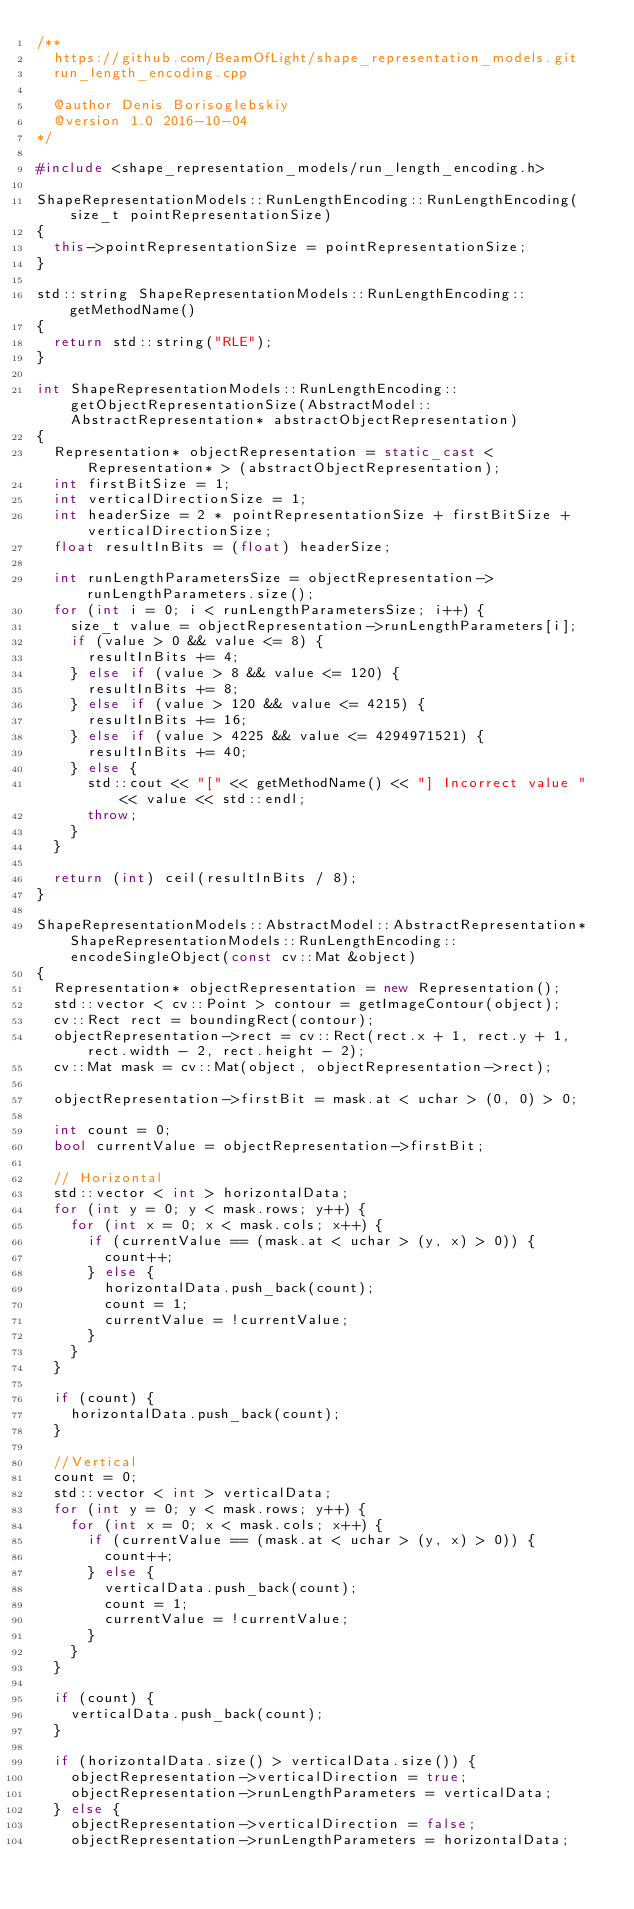Convert code to text. <code><loc_0><loc_0><loc_500><loc_500><_C++_>/**
  https://github.com/BeamOfLight/shape_representation_models.git
  run_length_encoding.cpp

  @author Denis Borisoglebskiy
  @version 1.0 2016-10-04
*/

#include <shape_representation_models/run_length_encoding.h>

ShapeRepresentationModels::RunLengthEncoding::RunLengthEncoding(size_t pointRepresentationSize)
{
  this->pointRepresentationSize = pointRepresentationSize;
}

std::string ShapeRepresentationModels::RunLengthEncoding::getMethodName()
{
  return std::string("RLE");
}

int ShapeRepresentationModels::RunLengthEncoding::getObjectRepresentationSize(AbstractModel::AbstractRepresentation* abstractObjectRepresentation)
{
  Representation* objectRepresentation = static_cast < Representation* > (abstractObjectRepresentation);
  int firstBitSize = 1;
  int verticalDirectionSize = 1;
  int headerSize = 2 * pointRepresentationSize + firstBitSize + verticalDirectionSize;
  float resultInBits = (float) headerSize;

  int runLengthParametersSize = objectRepresentation->runLengthParameters.size();
  for (int i = 0; i < runLengthParametersSize; i++) {
    size_t value = objectRepresentation->runLengthParameters[i];
    if (value > 0 && value <= 8) {
      resultInBits += 4;
    } else if (value > 8 && value <= 120) {
      resultInBits += 8;
    } else if (value > 120 && value <= 4215) {
      resultInBits += 16;
    } else if (value > 4225 && value <= 4294971521) {
      resultInBits += 40;
    } else {
      std::cout << "[" << getMethodName() << "] Incorrect value " << value << std::endl;
      throw;
    }
  }

  return (int) ceil(resultInBits / 8);
}

ShapeRepresentationModels::AbstractModel::AbstractRepresentation* ShapeRepresentationModels::RunLengthEncoding::encodeSingleObject(const cv::Mat &object)
{
  Representation* objectRepresentation = new Representation();
  std::vector < cv::Point > contour = getImageContour(object);
  cv::Rect rect = boundingRect(contour);
  objectRepresentation->rect = cv::Rect(rect.x + 1, rect.y + 1, rect.width - 2, rect.height - 2);
  cv::Mat mask = cv::Mat(object, objectRepresentation->rect);

  objectRepresentation->firstBit = mask.at < uchar > (0, 0) > 0;

  int count = 0;
  bool currentValue = objectRepresentation->firstBit;

  // Horizontal
  std::vector < int > horizontalData;
  for (int y = 0; y < mask.rows; y++) {
    for (int x = 0; x < mask.cols; x++) {
      if (currentValue == (mask.at < uchar > (y, x) > 0)) {
        count++;
      } else {
        horizontalData.push_back(count);
        count = 1;
        currentValue = !currentValue;
      }
    }
  }

  if (count) {
    horizontalData.push_back(count);
  }

  //Vertical
  count = 0;
  std::vector < int > verticalData;
  for (int y = 0; y < mask.rows; y++) {
    for (int x = 0; x < mask.cols; x++) {
      if (currentValue == (mask.at < uchar > (y, x) > 0)) {
        count++;
      } else {
        verticalData.push_back(count);
        count = 1;
        currentValue = !currentValue;
      }
    }
  }

  if (count) {
    verticalData.push_back(count);
  }

  if (horizontalData.size() > verticalData.size()) {
    objectRepresentation->verticalDirection = true;
    objectRepresentation->runLengthParameters = verticalData;
  } else {
    objectRepresentation->verticalDirection = false;
    objectRepresentation->runLengthParameters = horizontalData;</code> 